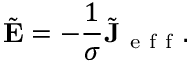<formula> <loc_0><loc_0><loc_500><loc_500>\tilde { E } = - \frac { 1 } { \sigma } \tilde { J } _ { e f f } .</formula> 